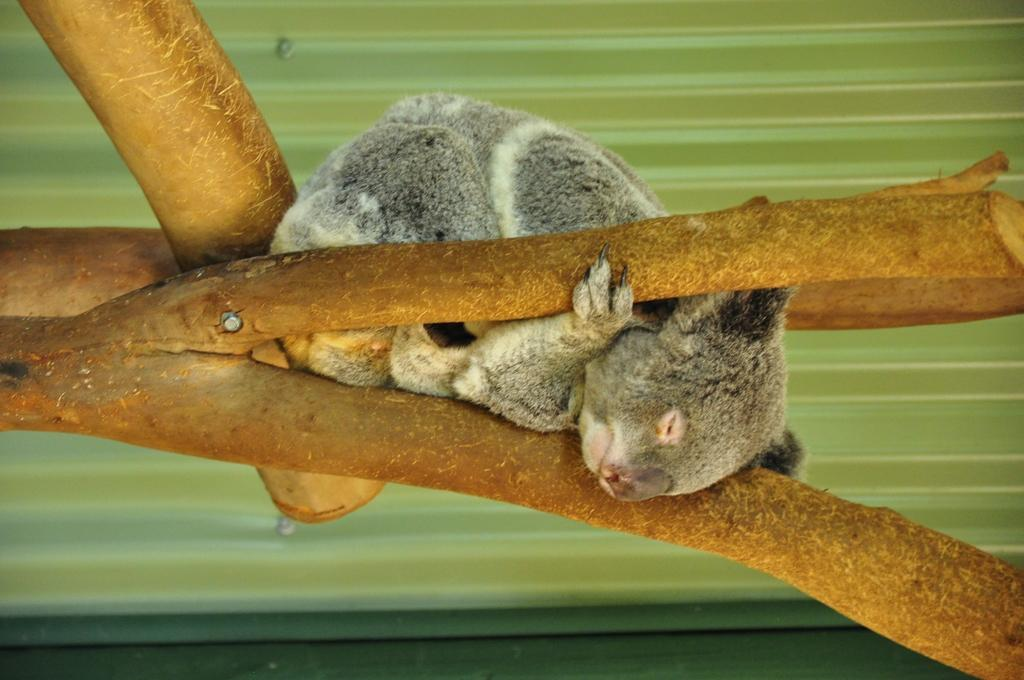What type of animal can be seen in the image? There is an animal in the image, but its specific type cannot be determined from the provided facts. Where is the animal located in the image? The animal is on a branch in the image. What color is the background of the image? The background of the image is green. What type of observation can be made about the yak in the image? There is no yak present in the image, so no observation can be made about it. What type of destruction is visible in the image? There is no destruction visible in the image; it features an animal on a branch with a green background. 